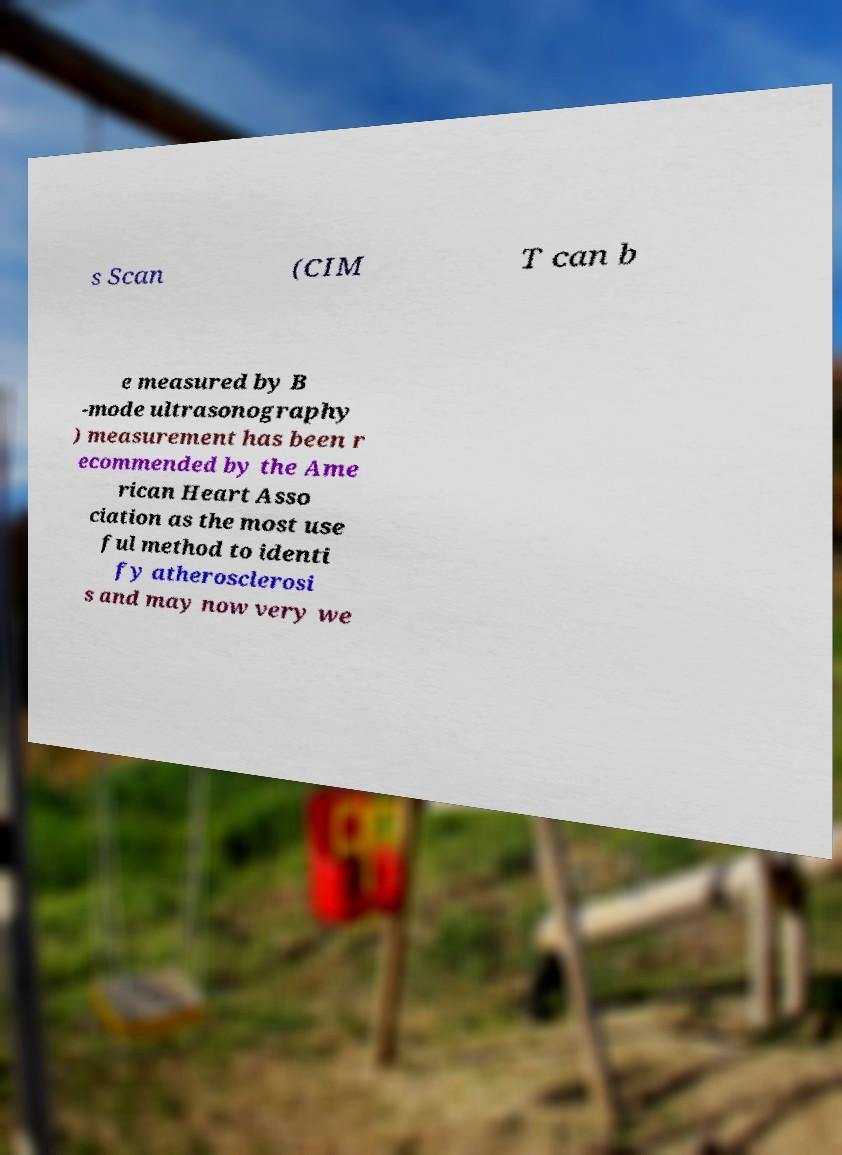For documentation purposes, I need the text within this image transcribed. Could you provide that? s Scan (CIM T can b e measured by B -mode ultrasonography ) measurement has been r ecommended by the Ame rican Heart Asso ciation as the most use ful method to identi fy atherosclerosi s and may now very we 